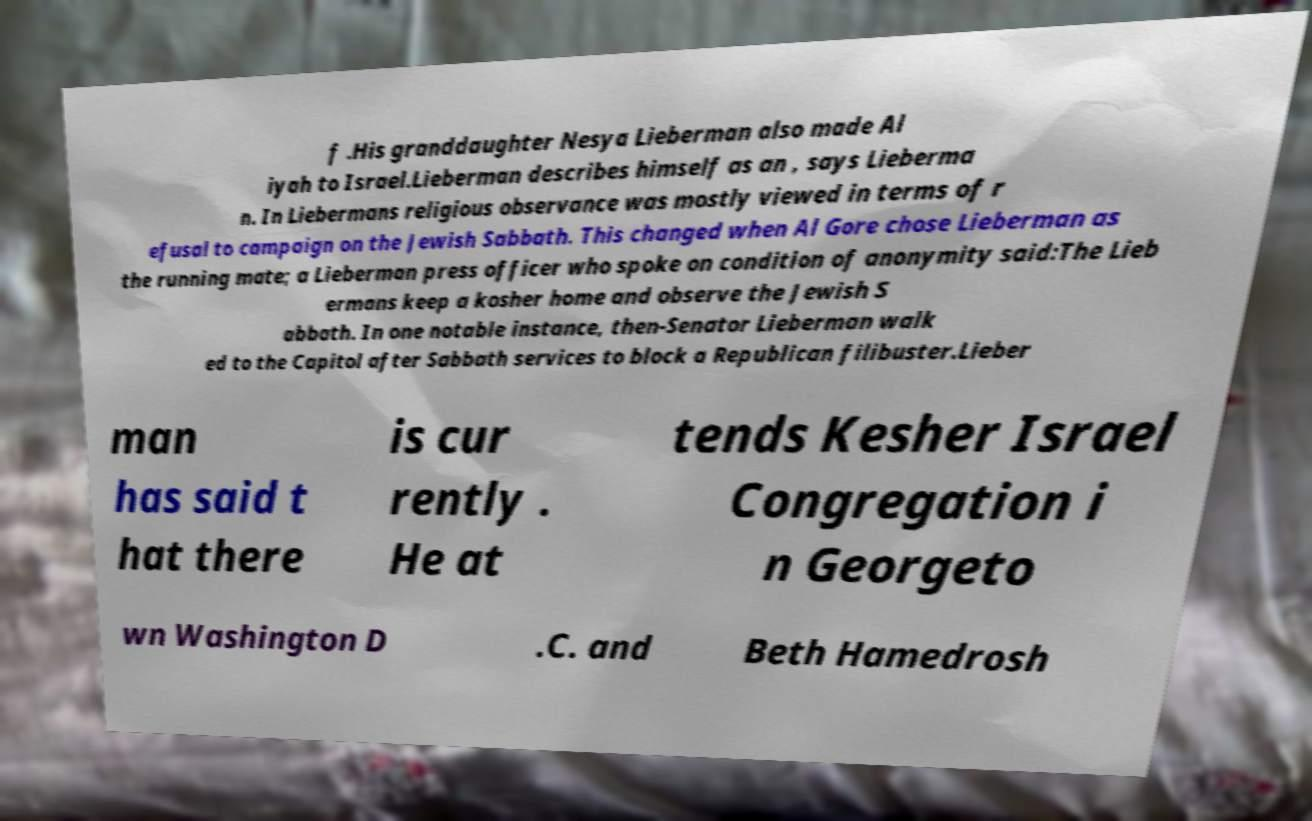What messages or text are displayed in this image? I need them in a readable, typed format. f .His granddaughter Nesya Lieberman also made Al iyah to Israel.Lieberman describes himself as an , says Lieberma n. In Liebermans religious observance was mostly viewed in terms of r efusal to campaign on the Jewish Sabbath. This changed when Al Gore chose Lieberman as the running mate; a Lieberman press officer who spoke on condition of anonymity said:The Lieb ermans keep a kosher home and observe the Jewish S abbath. In one notable instance, then-Senator Lieberman walk ed to the Capitol after Sabbath services to block a Republican filibuster.Lieber man has said t hat there is cur rently . He at tends Kesher Israel Congregation i n Georgeto wn Washington D .C. and Beth Hamedrosh 